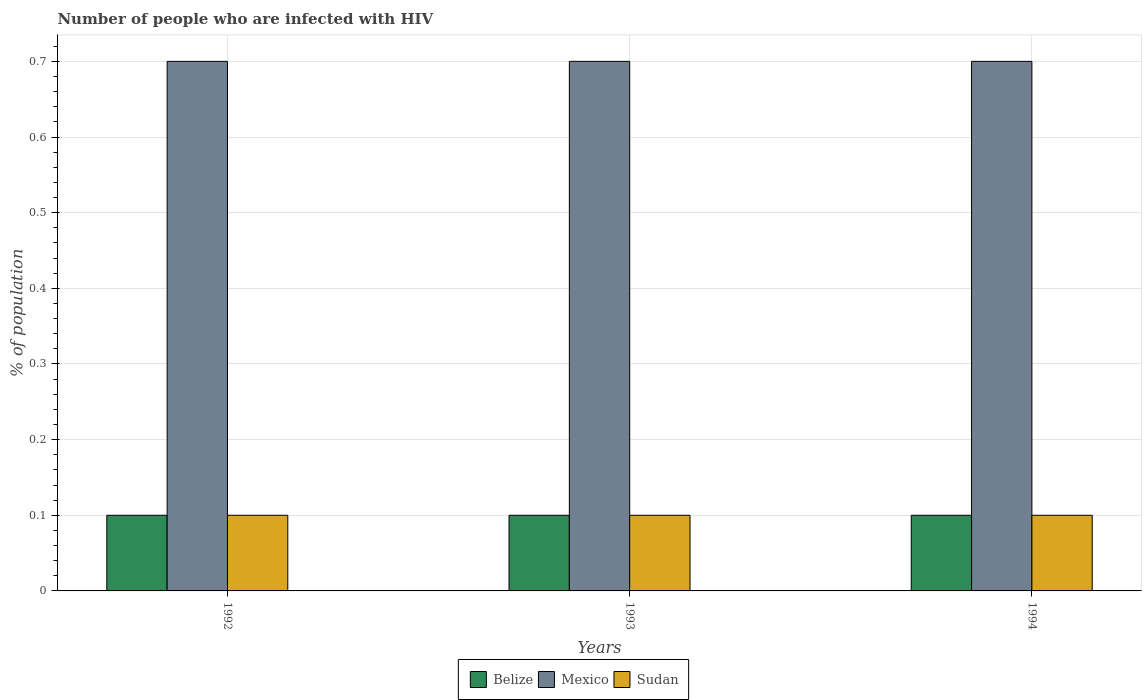How many bars are there on the 2nd tick from the left?
Your answer should be very brief. 3. What is the label of the 2nd group of bars from the left?
Your answer should be compact. 1993. What is the total percentage of HIV infected population in in Belize in the graph?
Make the answer very short. 0.3. What is the difference between the percentage of HIV infected population in in Mexico in 1992 and the percentage of HIV infected population in in Sudan in 1994?
Offer a terse response. 0.6. What is the average percentage of HIV infected population in in Mexico per year?
Provide a succinct answer. 0.7. In the year 1994, what is the difference between the percentage of HIV infected population in in Sudan and percentage of HIV infected population in in Belize?
Give a very brief answer. 0. Is the difference between the percentage of HIV infected population in in Sudan in 1992 and 1994 greater than the difference between the percentage of HIV infected population in in Belize in 1992 and 1994?
Your answer should be compact. No. What is the difference between the highest and the second highest percentage of HIV infected population in in Mexico?
Your answer should be compact. 0. In how many years, is the percentage of HIV infected population in in Mexico greater than the average percentage of HIV infected population in in Mexico taken over all years?
Provide a succinct answer. 3. What does the 3rd bar from the left in 1994 represents?
Make the answer very short. Sudan. What does the 3rd bar from the right in 1992 represents?
Your response must be concise. Belize. How many bars are there?
Keep it short and to the point. 9. Are the values on the major ticks of Y-axis written in scientific E-notation?
Provide a succinct answer. No. Does the graph contain grids?
Provide a short and direct response. Yes. Where does the legend appear in the graph?
Offer a very short reply. Bottom center. How many legend labels are there?
Keep it short and to the point. 3. What is the title of the graph?
Your answer should be very brief. Number of people who are infected with HIV. Does "Algeria" appear as one of the legend labels in the graph?
Give a very brief answer. No. What is the label or title of the X-axis?
Provide a succinct answer. Years. What is the label or title of the Y-axis?
Provide a short and direct response. % of population. What is the % of population in Sudan in 1992?
Ensure brevity in your answer.  0.1. What is the % of population of Sudan in 1993?
Keep it short and to the point. 0.1. What is the % of population of Belize in 1994?
Offer a very short reply. 0.1. Across all years, what is the minimum % of population of Belize?
Ensure brevity in your answer.  0.1. What is the total % of population of Mexico in the graph?
Make the answer very short. 2.1. What is the difference between the % of population of Mexico in 1992 and that in 1993?
Ensure brevity in your answer.  0. What is the difference between the % of population of Sudan in 1992 and that in 1994?
Keep it short and to the point. 0. What is the difference between the % of population of Sudan in 1993 and that in 1994?
Your answer should be very brief. 0. What is the difference between the % of population of Belize in 1992 and the % of population of Mexico in 1993?
Provide a succinct answer. -0.6. What is the difference between the % of population in Belize in 1992 and the % of population in Sudan in 1993?
Ensure brevity in your answer.  0. What is the difference between the % of population of Belize in 1992 and the % of population of Mexico in 1994?
Make the answer very short. -0.6. What is the difference between the % of population of Belize in 1992 and the % of population of Sudan in 1994?
Your answer should be very brief. 0. What is the difference between the % of population of Mexico in 1993 and the % of population of Sudan in 1994?
Provide a succinct answer. 0.6. What is the average % of population in Mexico per year?
Your answer should be very brief. 0.7. In the year 1992, what is the difference between the % of population of Belize and % of population of Mexico?
Provide a succinct answer. -0.6. In the year 1992, what is the difference between the % of population of Belize and % of population of Sudan?
Ensure brevity in your answer.  0. In the year 1993, what is the difference between the % of population of Belize and % of population of Sudan?
Keep it short and to the point. 0. In the year 1993, what is the difference between the % of population in Mexico and % of population in Sudan?
Offer a very short reply. 0.6. In the year 1994, what is the difference between the % of population in Belize and % of population in Mexico?
Make the answer very short. -0.6. In the year 1994, what is the difference between the % of population of Mexico and % of population of Sudan?
Provide a short and direct response. 0.6. What is the ratio of the % of population in Belize in 1992 to that in 1994?
Your answer should be very brief. 1. What is the ratio of the % of population of Sudan in 1992 to that in 1994?
Ensure brevity in your answer.  1. What is the ratio of the % of population of Mexico in 1993 to that in 1994?
Ensure brevity in your answer.  1. What is the ratio of the % of population in Sudan in 1993 to that in 1994?
Give a very brief answer. 1. What is the difference between the highest and the second highest % of population in Mexico?
Make the answer very short. 0. What is the difference between the highest and the second highest % of population in Sudan?
Offer a very short reply. 0. What is the difference between the highest and the lowest % of population of Belize?
Your answer should be compact. 0. What is the difference between the highest and the lowest % of population in Mexico?
Your answer should be compact. 0. What is the difference between the highest and the lowest % of population of Sudan?
Offer a terse response. 0. 